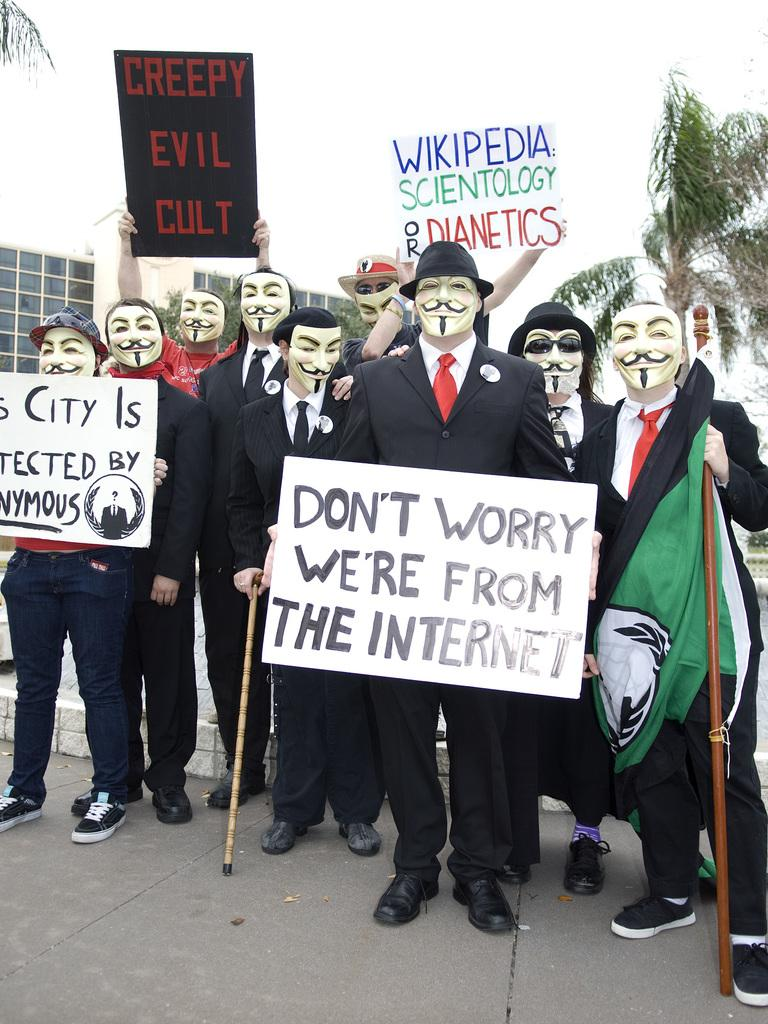<image>
Relay a brief, clear account of the picture shown. Group of protesters holding a sign which says Don't worry we're from the internet. 